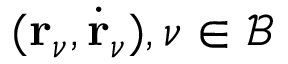<formula> <loc_0><loc_0><loc_500><loc_500>{ ( r _ { \nu } , \dot { r } _ { \nu } ) , \nu \in \mathcal { B } }</formula> 